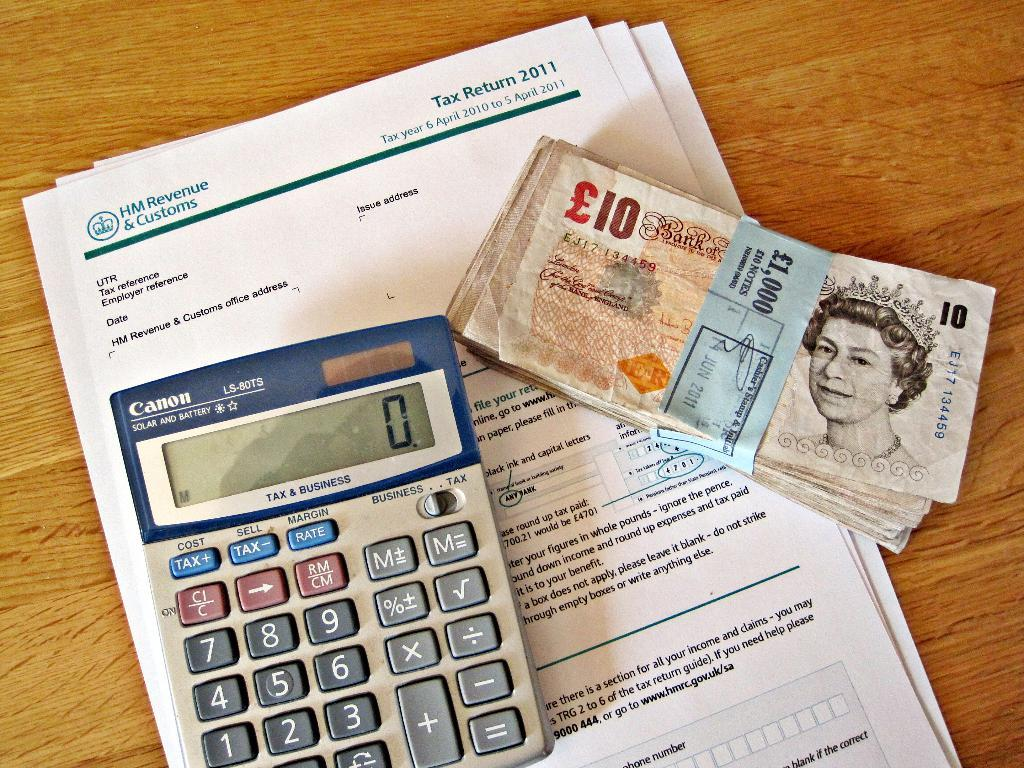<image>
Provide a brief description of the given image. A stack of ten pound notes sits next to a calculator and on some tax return papers. 